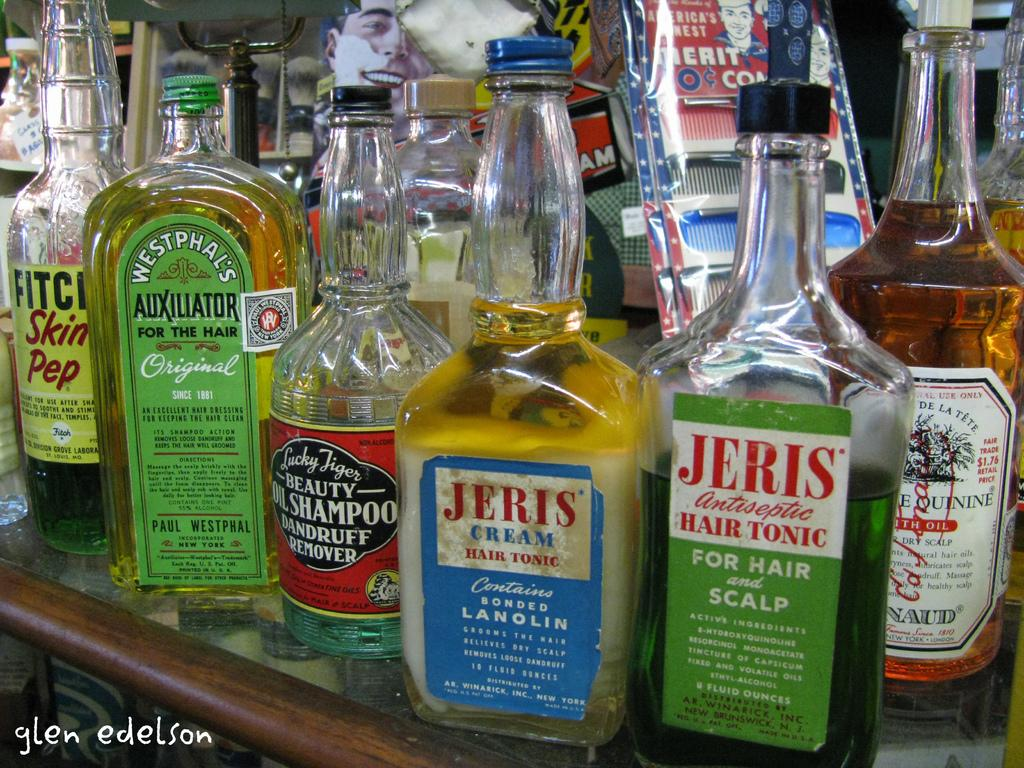<image>
Provide a brief description of the given image. Several old hair-care bottles are crowded together, including cream hair tonic and oil shampoo for dandruff. 